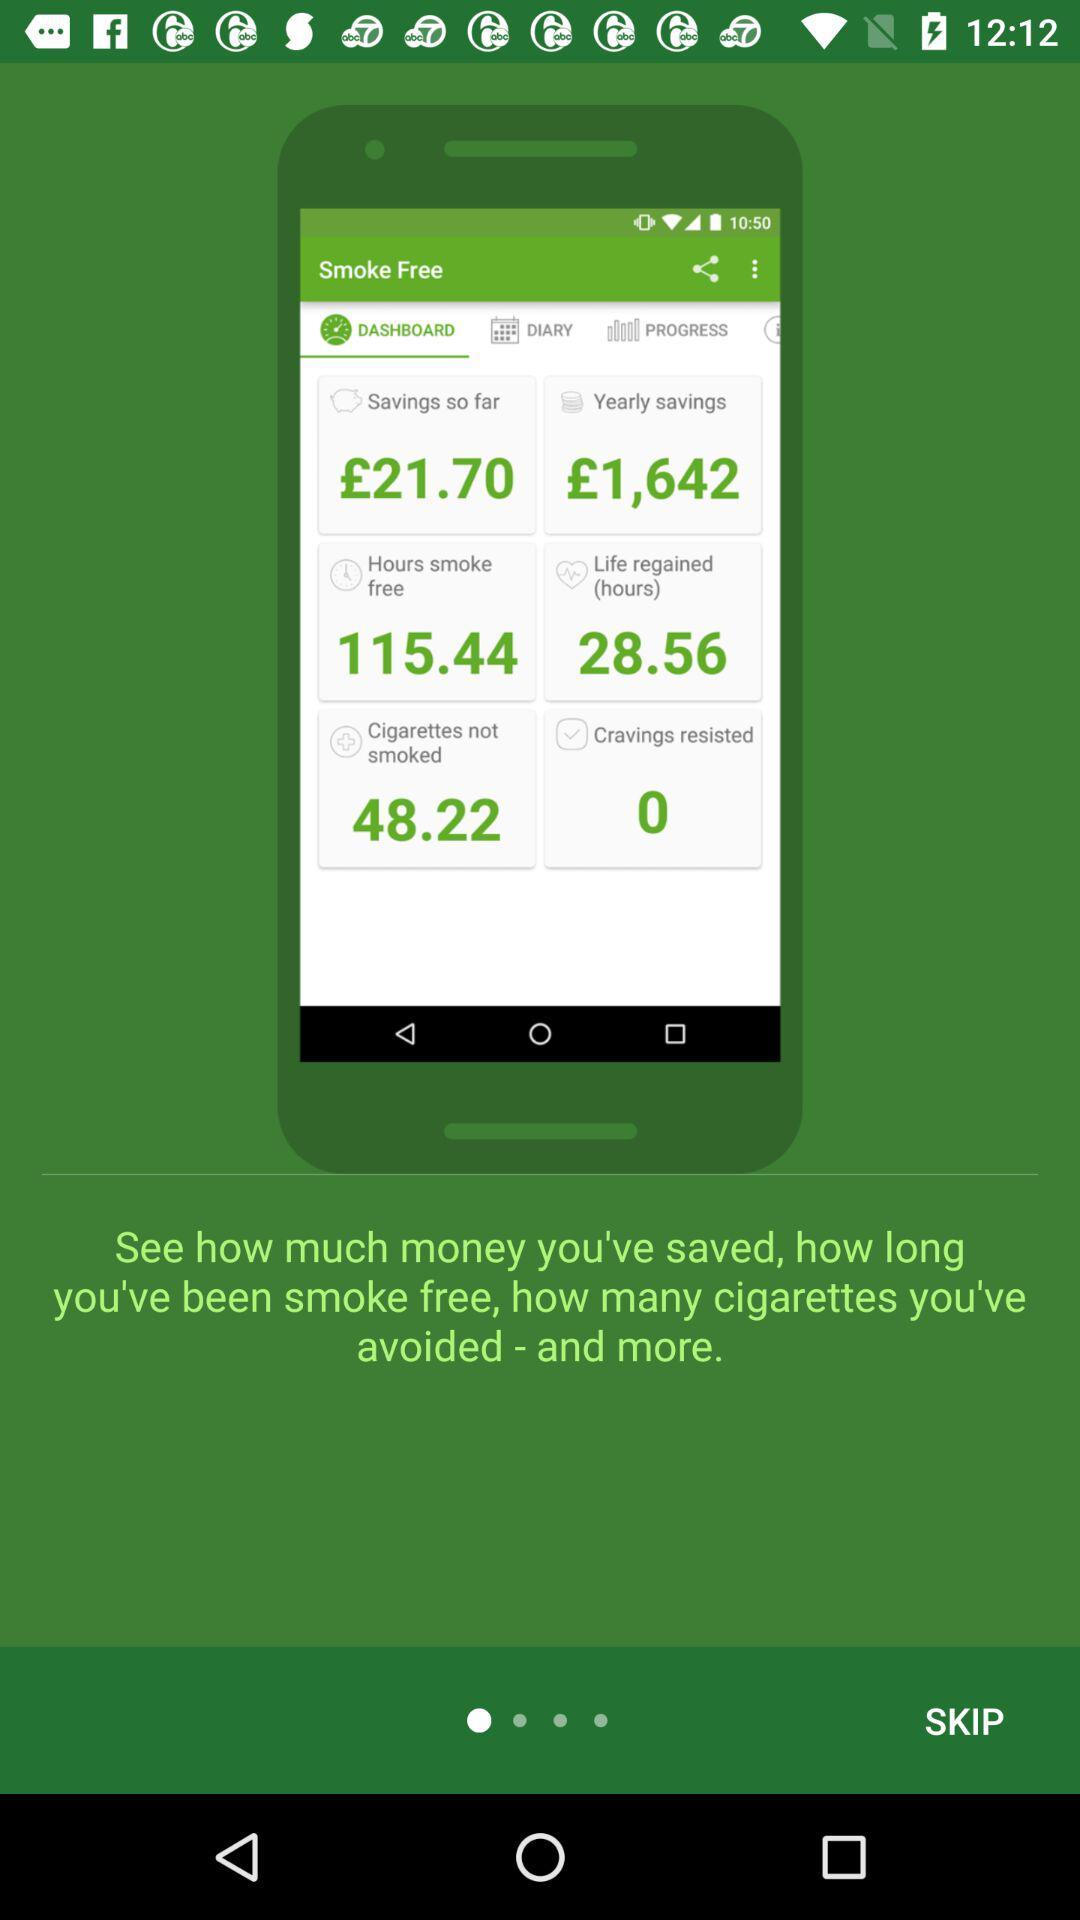How much is "Saving so far"?
Answer the question using a single word or phrase. It is £21.70. 